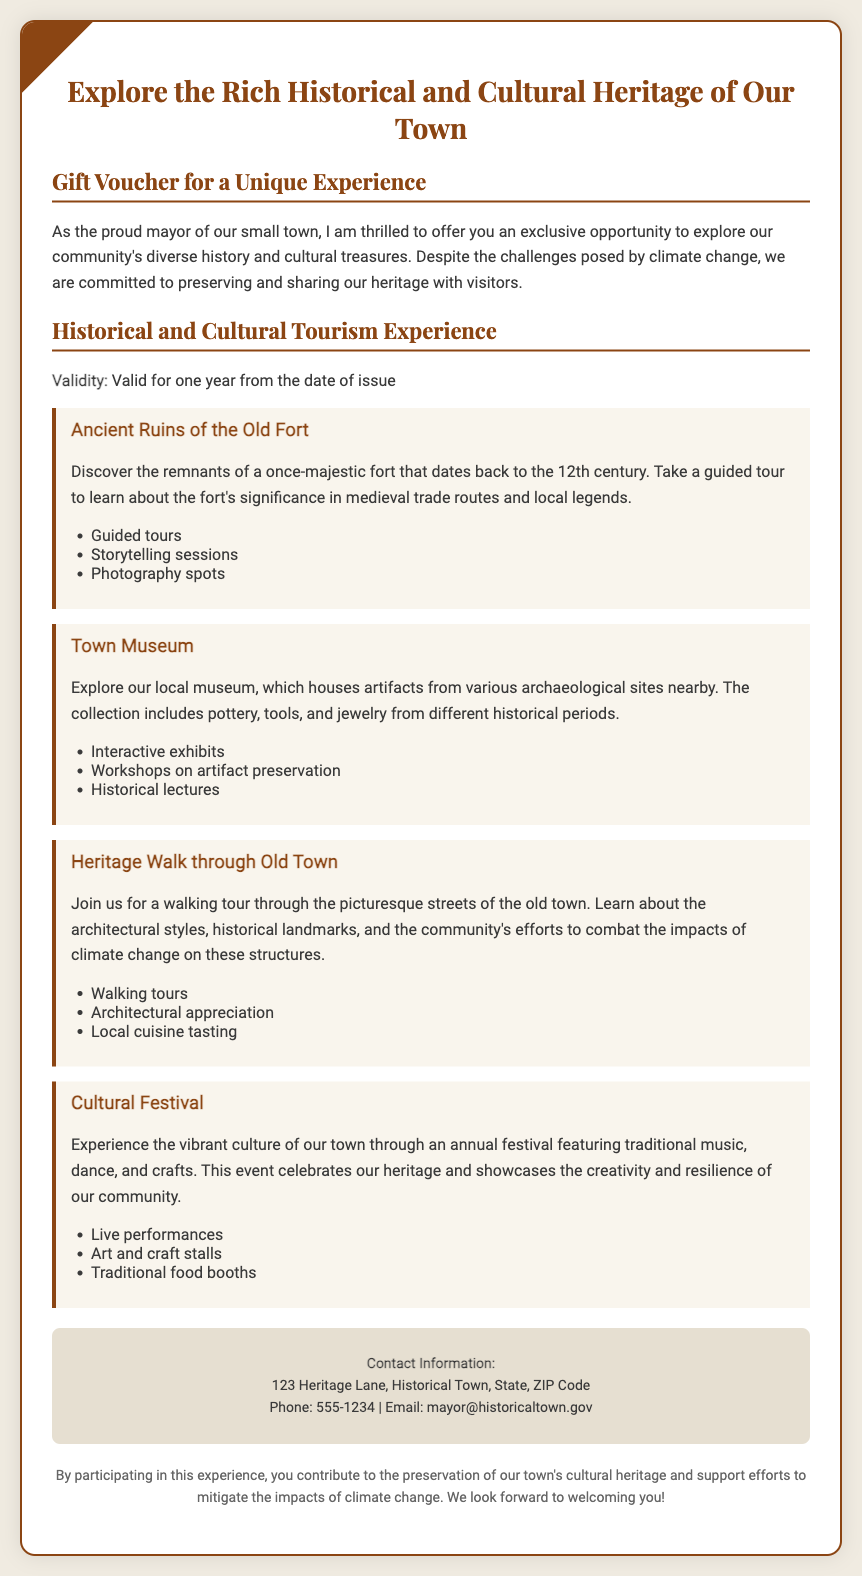what is the title of the gift voucher? The title of the gift voucher is displayed prominently at the top of the document.
Answer: Explore the Rich Historical and Cultural Heritage of Our Town what is the validity period of the voucher? The voucher's validity period is mentioned in the section detailing the Historical and Cultural Tourism Experience.
Answer: Valid for one year from the date of issue what historical site is featured in the voucher? The voucher lists several historical locations, with the Old Fort being one of them.
Answer: Ancient Ruins of the Old Fort what activities are included in the Town Museum experience? The document provides a list of activities available at the Town Museum.
Answer: Interactive exhibits, Workshops on artifact preservation, Historical lectures what is the focus of the Heritage Walk? The document outlines the main focus of the Heritage Walk.
Answer: Architectural styles, historical landmarks, climate change impacts what kind of performances can visitors expect at the Cultural Festival? The Cultural Festival section indicates what kind of entertainment will be at the event.
Answer: Live performances why is participating in this experience important? The footer includes a statement about the significance of participation in the experience.
Answer: Preservation of our town's cultural heritage and support efforts to mitigate climate change 